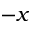Convert formula to latex. <formula><loc_0><loc_0><loc_500><loc_500>- x</formula> 